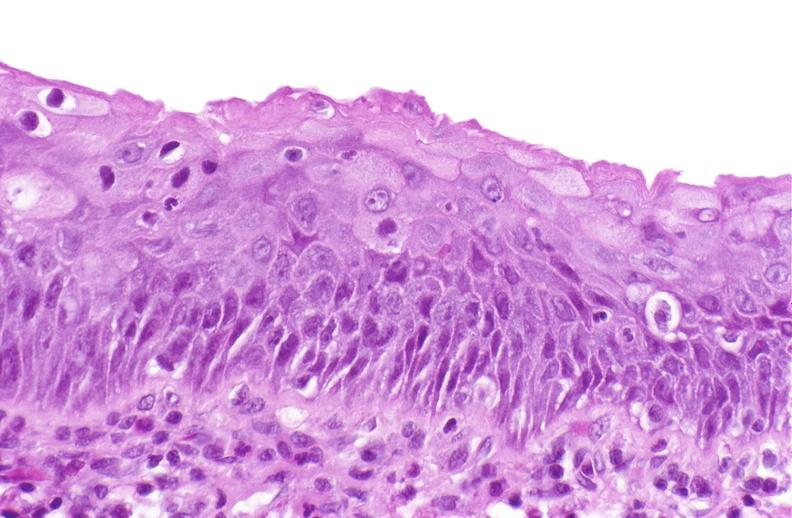does this image show squamous metaplasia, renal pelvis due to nephrolithiasis?
Answer the question using a single word or phrase. Yes 